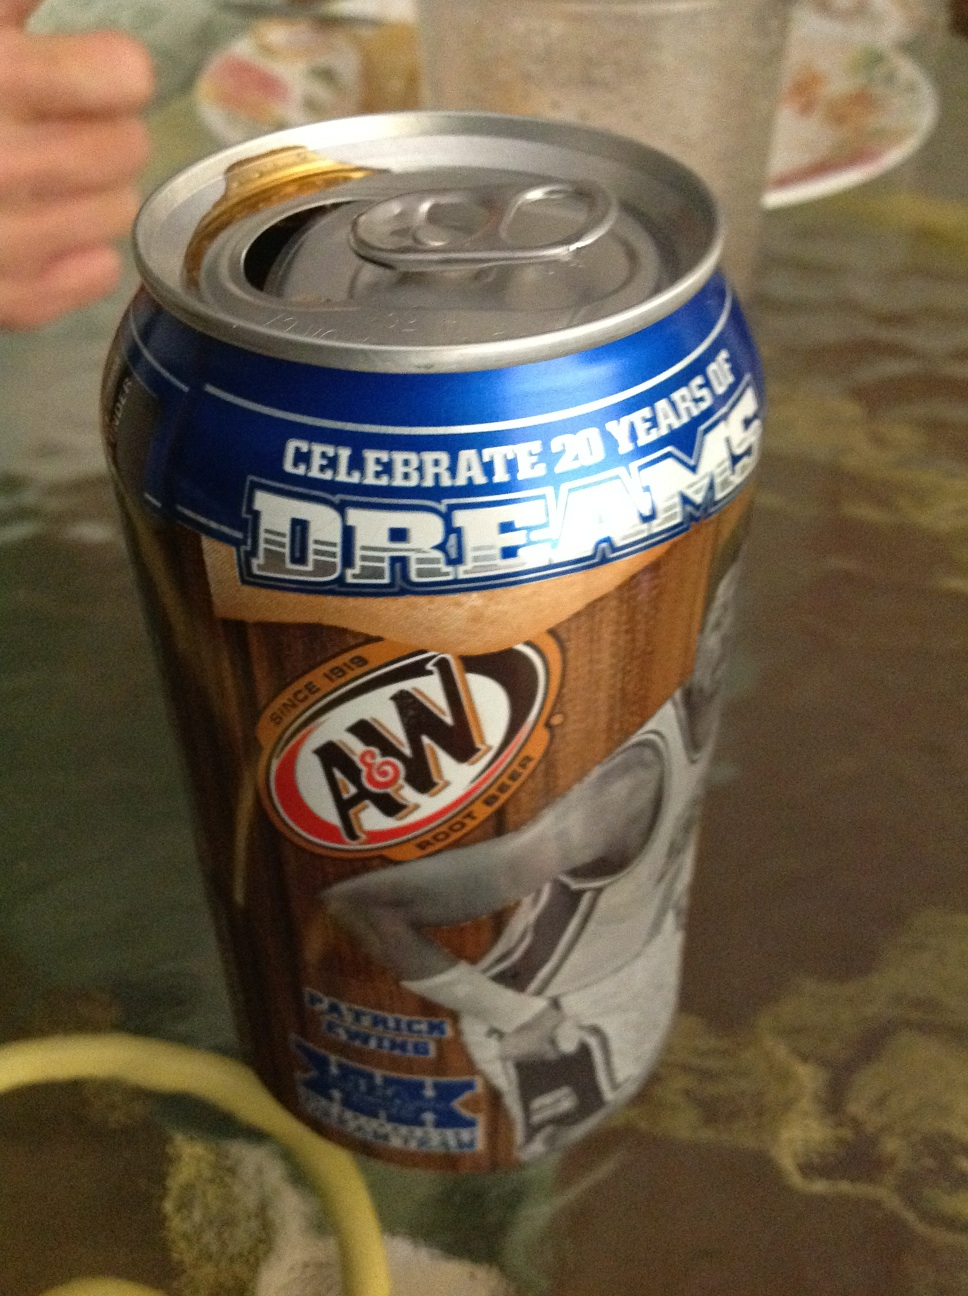Create a short fictional story involving this can of A&W Root Beer. In a small town where everyone knew each other, Robbie found an old, dusty can of A&W Root Beer in his grandfather's attic. Intrigued by its special design celebrating 20 years of dreams, he asked his grandfather about it. His grandfather smiled and recounted the summer of 2023, a year where the local basketball team won the state championship and every player, including Robbie's father, received these special cans. It was more than just a drink; it was a token of dreams realized and shared victories. Robbie cherished the can, seeing it as a symbol of his family's legacy and dreams. 